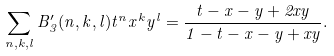<formula> <loc_0><loc_0><loc_500><loc_500>\sum _ { n , k , l } B ^ { \prime } _ { 3 } ( n , k , l ) t ^ { n } x ^ { k } y ^ { l } = \frac { t - x - y + 2 x y } { 1 - t - x - y + x y } .</formula> 